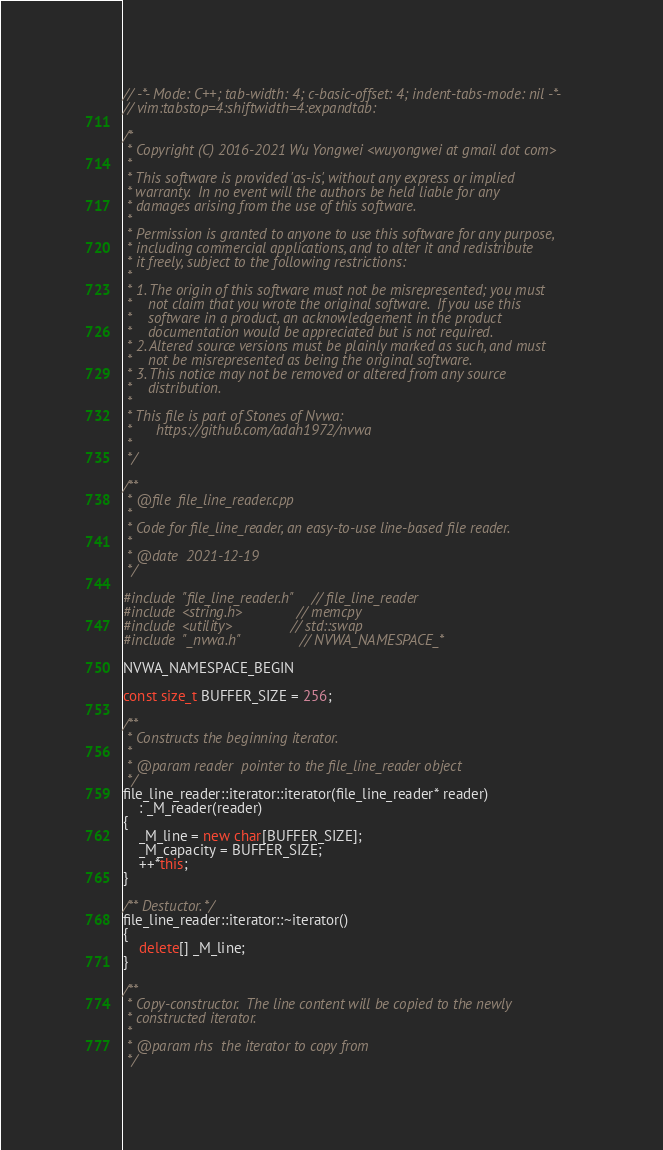Convert code to text. <code><loc_0><loc_0><loc_500><loc_500><_C++_>// -*- Mode: C++; tab-width: 4; c-basic-offset: 4; indent-tabs-mode: nil -*-
// vim:tabstop=4:shiftwidth=4:expandtab:

/*
 * Copyright (C) 2016-2021 Wu Yongwei <wuyongwei at gmail dot com>
 *
 * This software is provided 'as-is', without any express or implied
 * warranty.  In no event will the authors be held liable for any
 * damages arising from the use of this software.
 *
 * Permission is granted to anyone to use this software for any purpose,
 * including commercial applications, and to alter it and redistribute
 * it freely, subject to the following restrictions:
 *
 * 1. The origin of this software must not be misrepresented; you must
 *    not claim that you wrote the original software.  If you use this
 *    software in a product, an acknowledgement in the product
 *    documentation would be appreciated but is not required.
 * 2. Altered source versions must be plainly marked as such, and must
 *    not be misrepresented as being the original software.
 * 3. This notice may not be removed or altered from any source
 *    distribution.
 *
 * This file is part of Stones of Nvwa:
 *      https://github.com/adah1972/nvwa
 *
 */

/**
 * @file  file_line_reader.cpp
 *
 * Code for file_line_reader, an easy-to-use line-based file reader.
 *
 * @date  2021-12-19
 */

#include "file_line_reader.h"   // file_line_reader
#include <string.h>             // memcpy
#include <utility>              // std::swap
#include "_nvwa.h"              // NVWA_NAMESPACE_*

NVWA_NAMESPACE_BEGIN

const size_t BUFFER_SIZE = 256;

/**
 * Constructs the beginning iterator.
 *
 * @param reader  pointer to the file_line_reader object
 */
file_line_reader::iterator::iterator(file_line_reader* reader)
    : _M_reader(reader)
{
    _M_line = new char[BUFFER_SIZE];
    _M_capacity = BUFFER_SIZE;
    ++*this;
}

/** Destuctor. */
file_line_reader::iterator::~iterator()
{
    delete[] _M_line;
}

/**
 * Copy-constructor.  The line content will be copied to the newly
 * constructed iterator.
 *
 * @param rhs  the iterator to copy from
 */</code> 